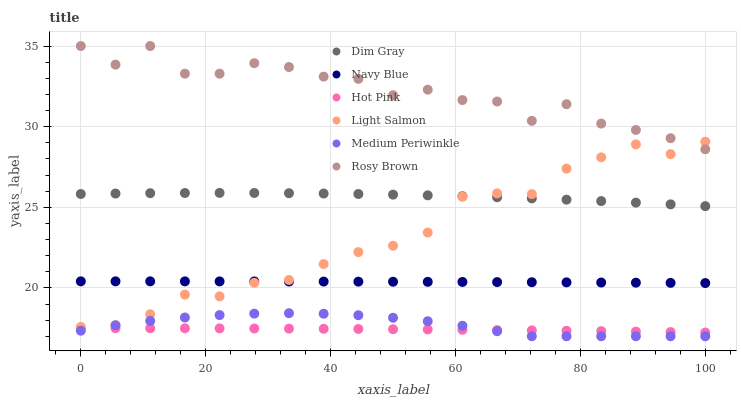Does Hot Pink have the minimum area under the curve?
Answer yes or no. Yes. Does Rosy Brown have the maximum area under the curve?
Answer yes or no. Yes. Does Dim Gray have the minimum area under the curve?
Answer yes or no. No. Does Dim Gray have the maximum area under the curve?
Answer yes or no. No. Is Navy Blue the smoothest?
Answer yes or no. Yes. Is Rosy Brown the roughest?
Answer yes or no. Yes. Is Dim Gray the smoothest?
Answer yes or no. No. Is Dim Gray the roughest?
Answer yes or no. No. Does Medium Periwinkle have the lowest value?
Answer yes or no. Yes. Does Dim Gray have the lowest value?
Answer yes or no. No. Does Rosy Brown have the highest value?
Answer yes or no. Yes. Does Dim Gray have the highest value?
Answer yes or no. No. Is Dim Gray less than Rosy Brown?
Answer yes or no. Yes. Is Dim Gray greater than Hot Pink?
Answer yes or no. Yes. Does Light Salmon intersect Dim Gray?
Answer yes or no. Yes. Is Light Salmon less than Dim Gray?
Answer yes or no. No. Is Light Salmon greater than Dim Gray?
Answer yes or no. No. Does Dim Gray intersect Rosy Brown?
Answer yes or no. No. 